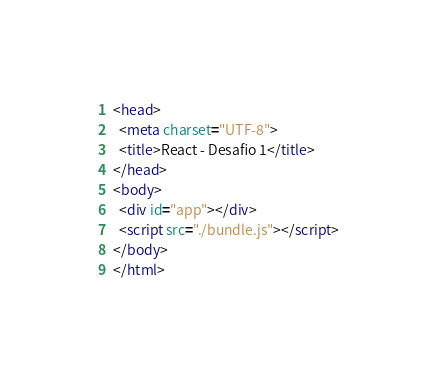Convert code to text. <code><loc_0><loc_0><loc_500><loc_500><_HTML_><head>
  <meta charset="UTF-8">
  <title>React - Desafio 1</title>
</head>
<body>
  <div id="app"></div>
  <script src="./bundle.js"></script>
</body>
</html>
</code> 